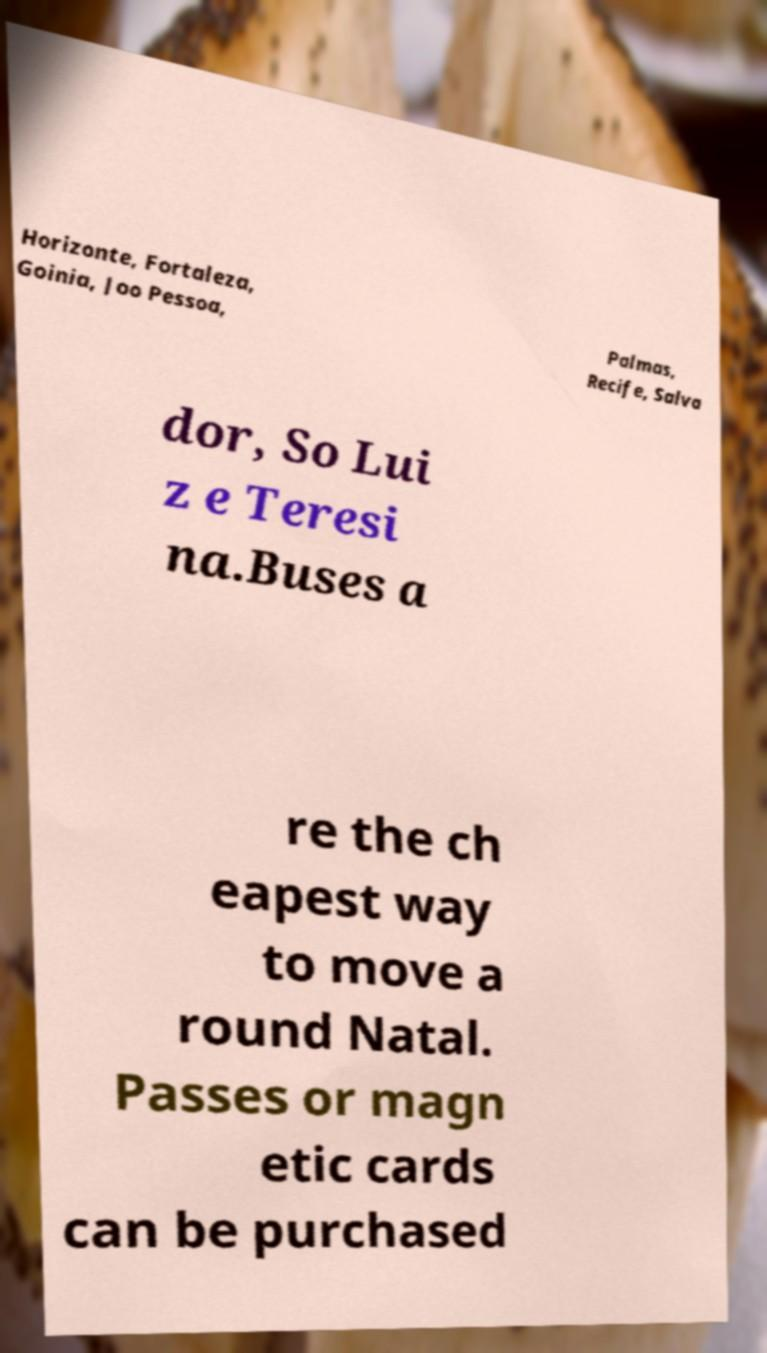Please read and relay the text visible in this image. What does it say? Horizonte, Fortaleza, Goinia, Joo Pessoa, Palmas, Recife, Salva dor, So Lui z e Teresi na.Buses a re the ch eapest way to move a round Natal. Passes or magn etic cards can be purchased 